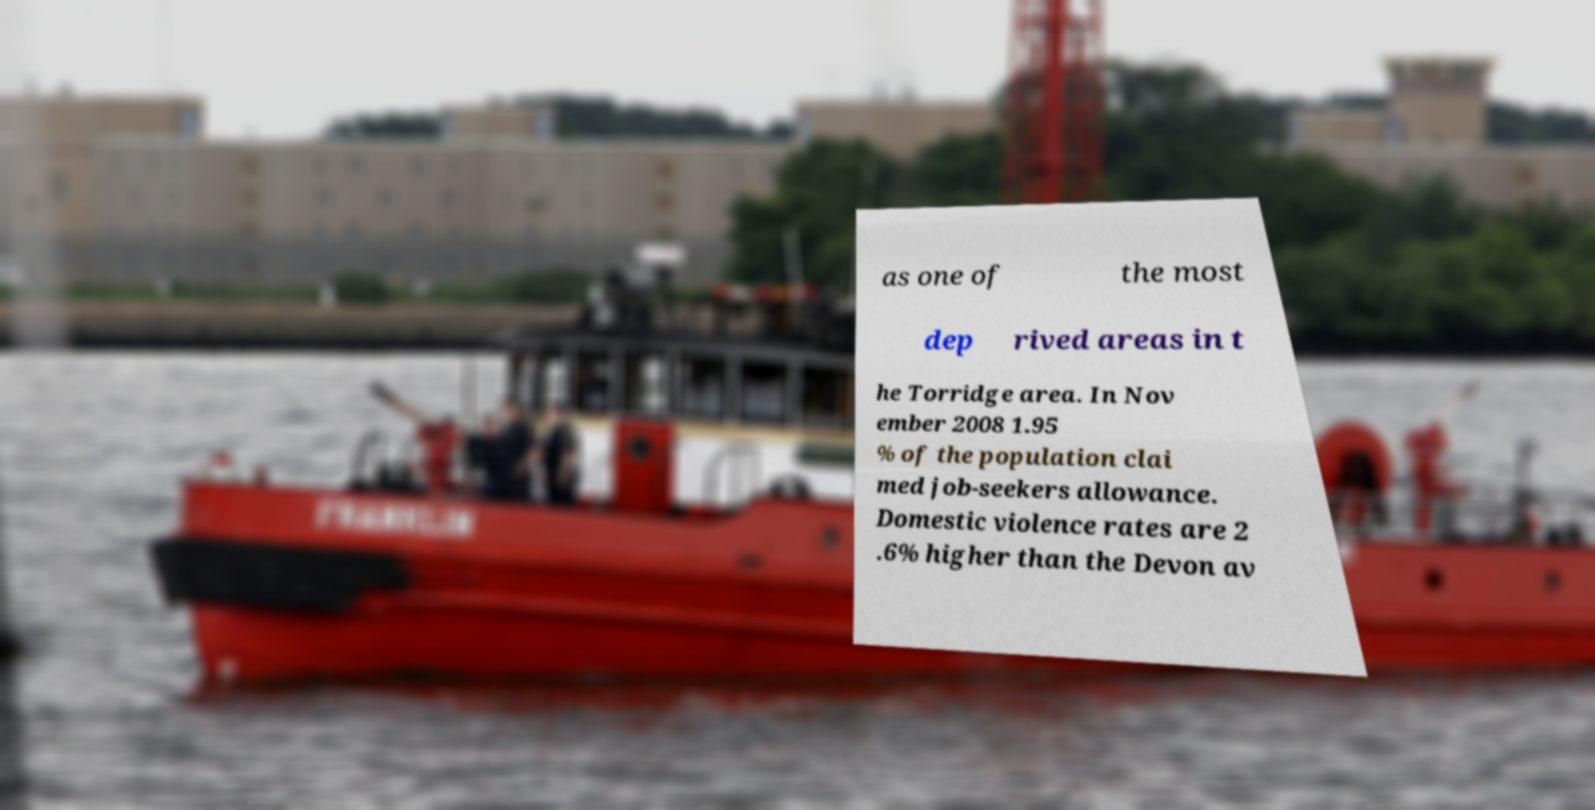What messages or text are displayed in this image? I need them in a readable, typed format. as one of the most dep rived areas in t he Torridge area. In Nov ember 2008 1.95 % of the population clai med job-seekers allowance. Domestic violence rates are 2 .6% higher than the Devon av 